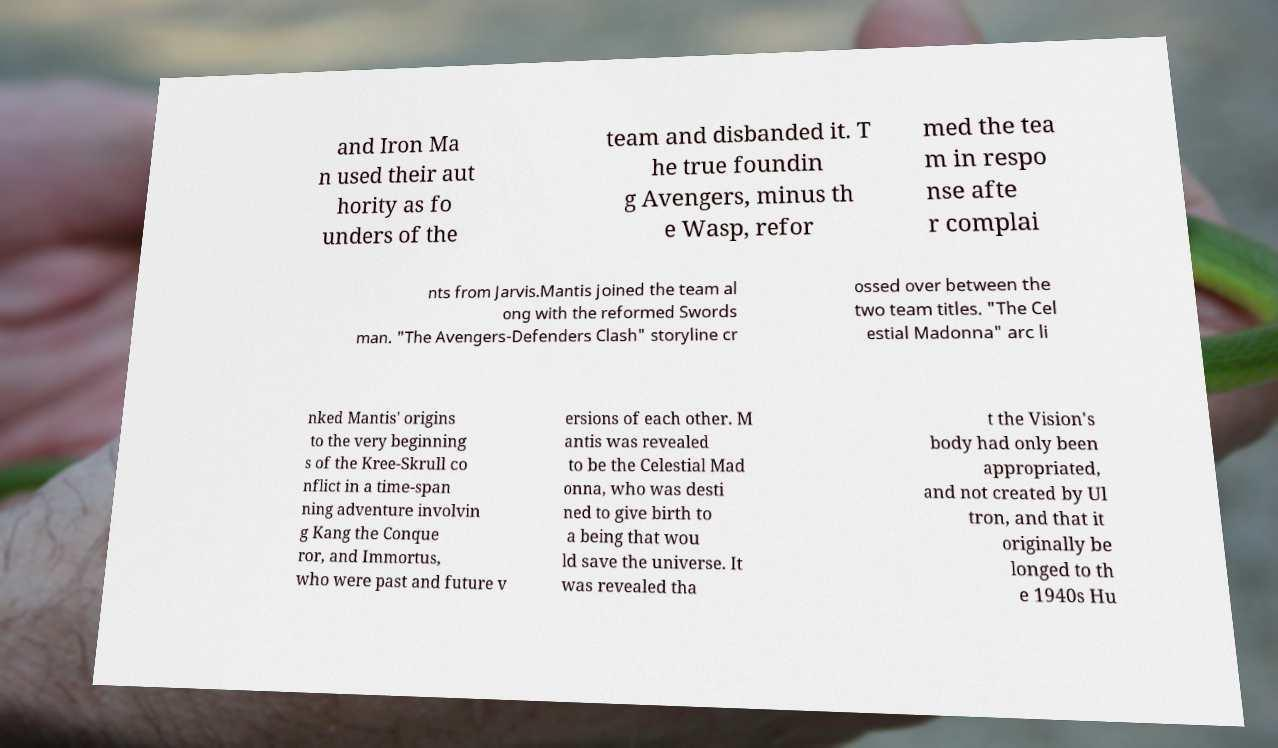Please read and relay the text visible in this image. What does it say? and Iron Ma n used their aut hority as fo unders of the team and disbanded it. T he true foundin g Avengers, minus th e Wasp, refor med the tea m in respo nse afte r complai nts from Jarvis.Mantis joined the team al ong with the reformed Swords man. "The Avengers-Defenders Clash" storyline cr ossed over between the two team titles. "The Cel estial Madonna" arc li nked Mantis' origins to the very beginning s of the Kree-Skrull co nflict in a time-span ning adventure involvin g Kang the Conque ror, and Immortus, who were past and future v ersions of each other. M antis was revealed to be the Celestial Mad onna, who was desti ned to give birth to a being that wou ld save the universe. It was revealed tha t the Vision's body had only been appropriated, and not created by Ul tron, and that it originally be longed to th e 1940s Hu 